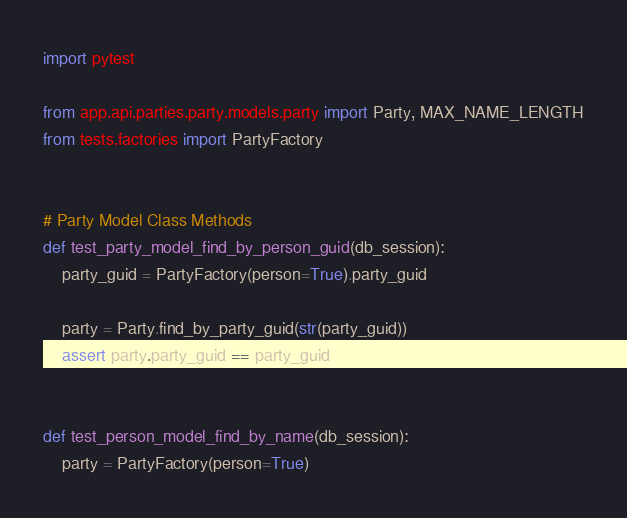<code> <loc_0><loc_0><loc_500><loc_500><_Python_>import pytest

from app.api.parties.party.models.party import Party, MAX_NAME_LENGTH
from tests.factories import PartyFactory


# Party Model Class Methods
def test_party_model_find_by_person_guid(db_session):
    party_guid = PartyFactory(person=True).party_guid

    party = Party.find_by_party_guid(str(party_guid))
    assert party.party_guid == party_guid


def test_person_model_find_by_name(db_session):
    party = PartyFactory(person=True)
</code> 